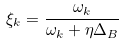Convert formula to latex. <formula><loc_0><loc_0><loc_500><loc_500>\xi _ { k } = \frac { \omega _ { k } } { \omega _ { k } + \eta \Delta _ { B } }</formula> 